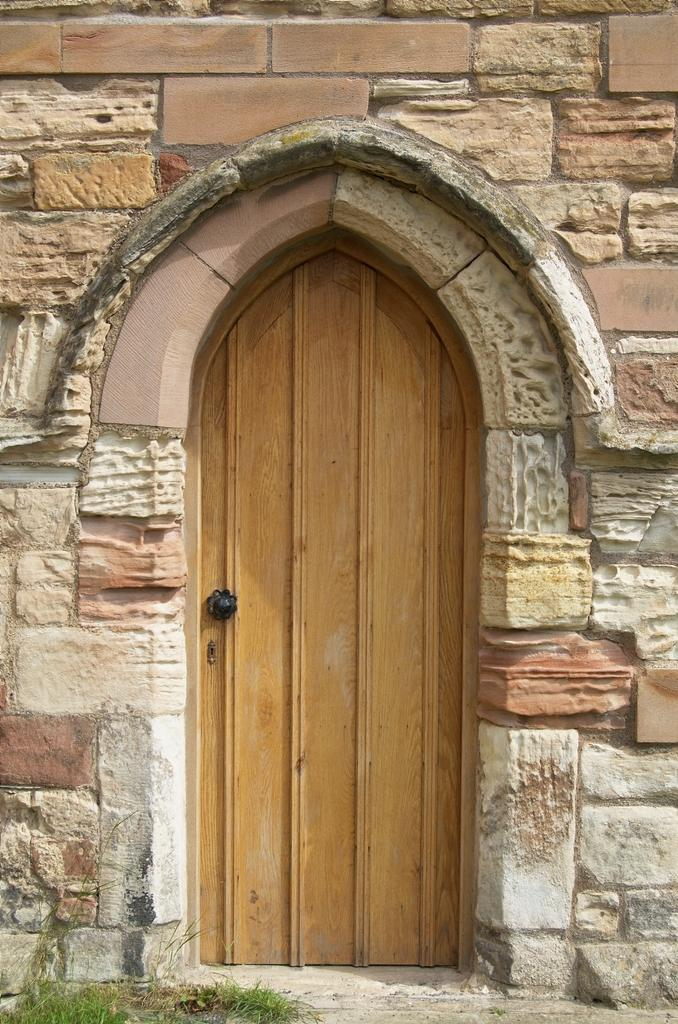What type of structure is visible in the image? There is a stone wall in the image. What feature is attached to the stone wall? There is a wooden door on the wall. What type of vegetation can be seen in the image? Grass is present in the bottom left corner of the image. How many kittens are playing in the grass in the image? There are no kittens present in the image; it only features a stone wall, a wooden door, and grass. What time of day is it in the image, based on the presence of shadows? The provided facts do not mention shadows or the time of day, so it cannot be determined from the image. 